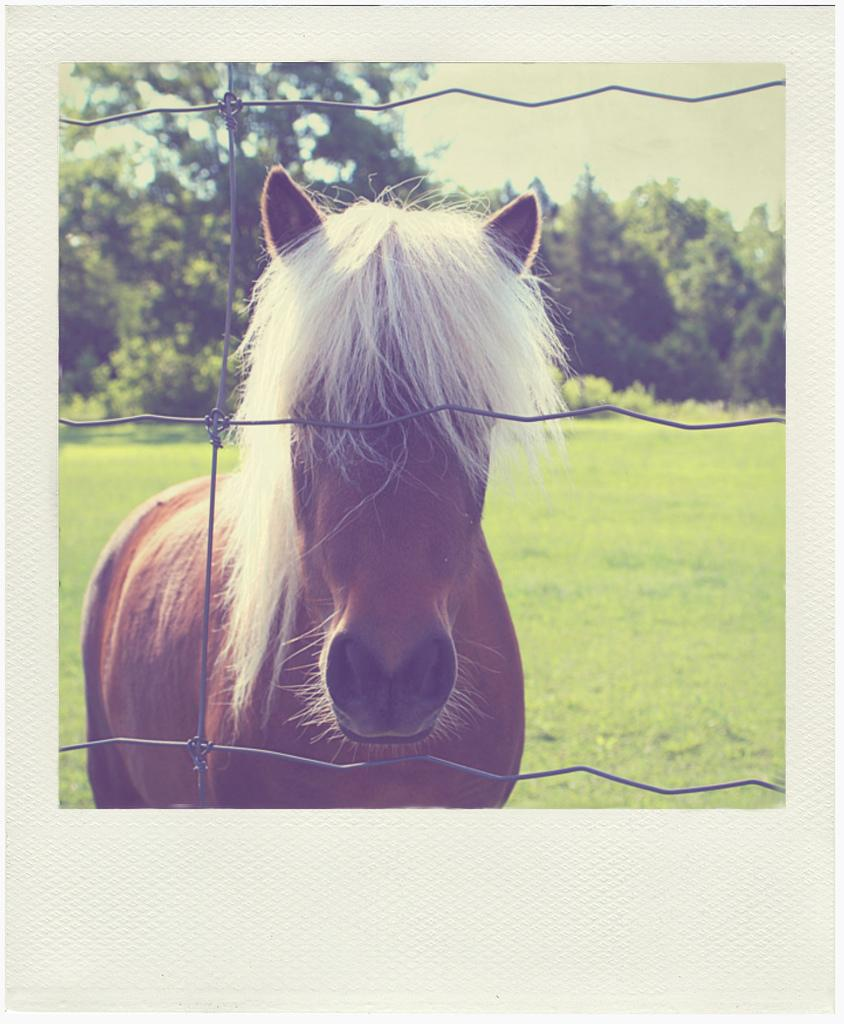What animal is present in the image? There is a horse in the image. What color is the horse? The horse is brown in color. What can be seen in the background of the image? There are trees visible in the background of the image. What type of agreement is being discussed between the horse and the trees in the image? There is no discussion or agreement present in the image; it simply shows a brown horse with trees in the background. 